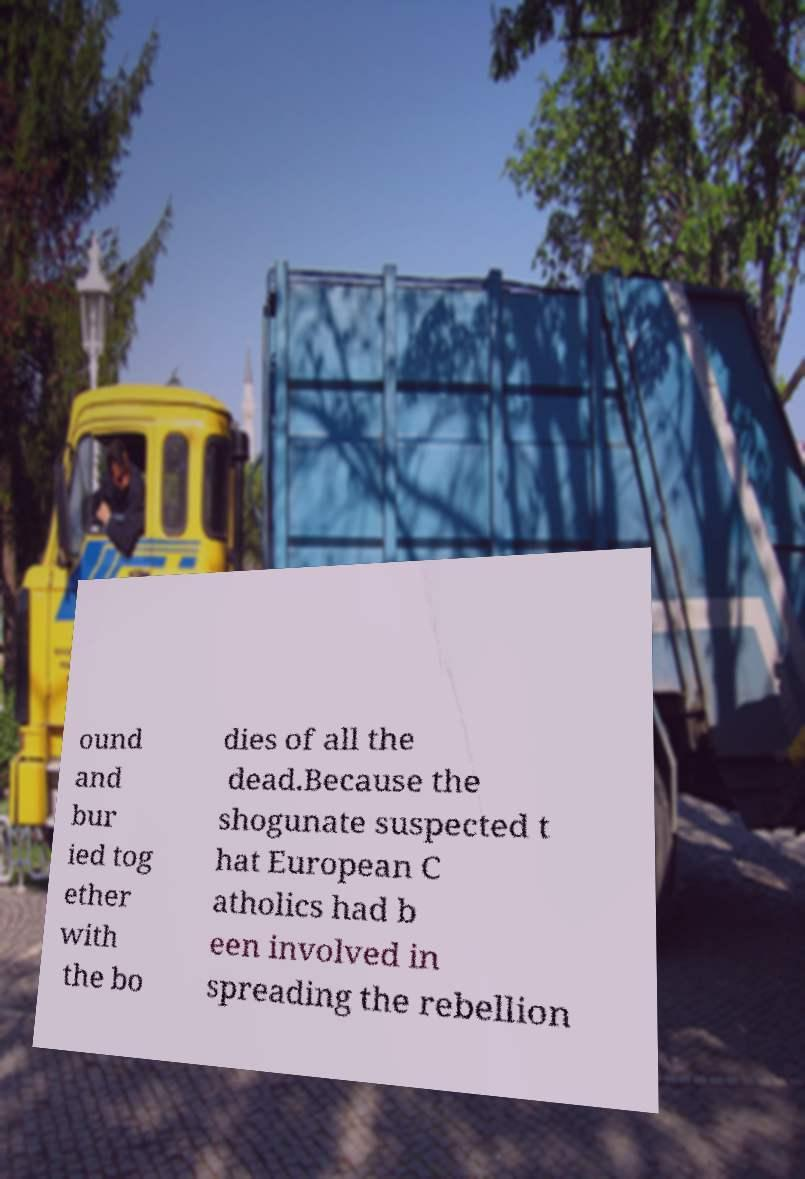Could you extract and type out the text from this image? ound and bur ied tog ether with the bo dies of all the dead.Because the shogunate suspected t hat European C atholics had b een involved in spreading the rebellion 